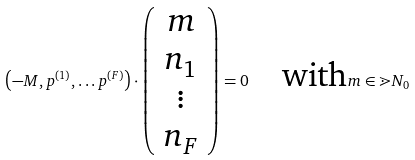<formula> <loc_0><loc_0><loc_500><loc_500>\left ( - M , p ^ { ( 1 ) } , \dots p ^ { ( F ) } \right ) \cdot \left ( \begin{array} { c } m \\ n _ { 1 } \\ \vdots \\ n _ { F } \end{array} \right ) = 0 \quad \text {with} m \in \mathbb { m } { N } _ { 0 }</formula> 